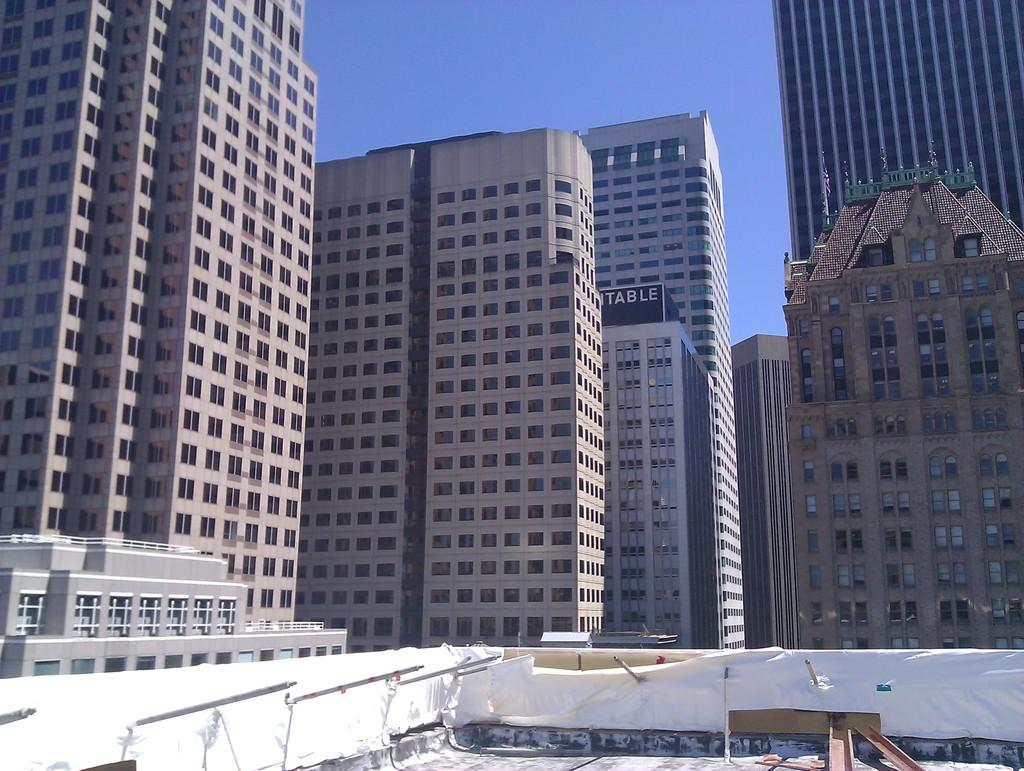What is located at the bottom of the image? There are objects and rods at the bottom of the image. What can be seen in the distance in the image? There are buildings in the background of the image. What architectural features are visible in the background of the image? There are windows visible in the background of the image. What is written or displayed on a wall in the background of the image? There is text written on a wall in the background of the image. What part of the natural environment is visible in the image? The sky is visible in the background of the image. Can you see a farmer with a pig and a gun in the image? There is no farmer, pig, or gun present in the image. 